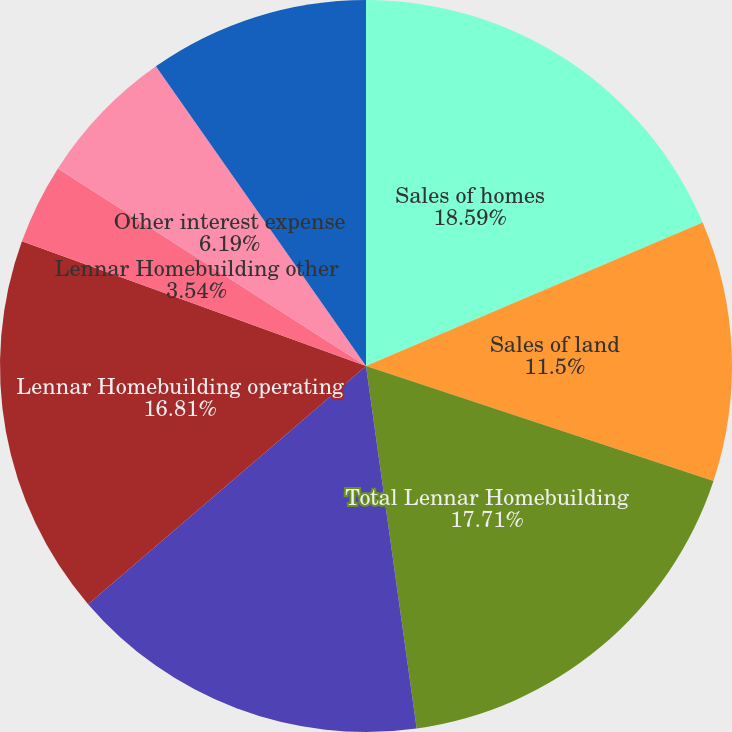Convert chart. <chart><loc_0><loc_0><loc_500><loc_500><pie_chart><fcel>Sales of homes<fcel>Sales of land<fcel>Total Lennar Homebuilding<fcel>Selling general and<fcel>Lennar Homebuilding operating<fcel>Lennar Homebuilding other<fcel>Other interest expense<fcel>Lennar Financial Services<nl><fcel>18.58%<fcel>11.5%<fcel>17.7%<fcel>15.93%<fcel>16.81%<fcel>3.54%<fcel>6.19%<fcel>9.73%<nl></chart> 